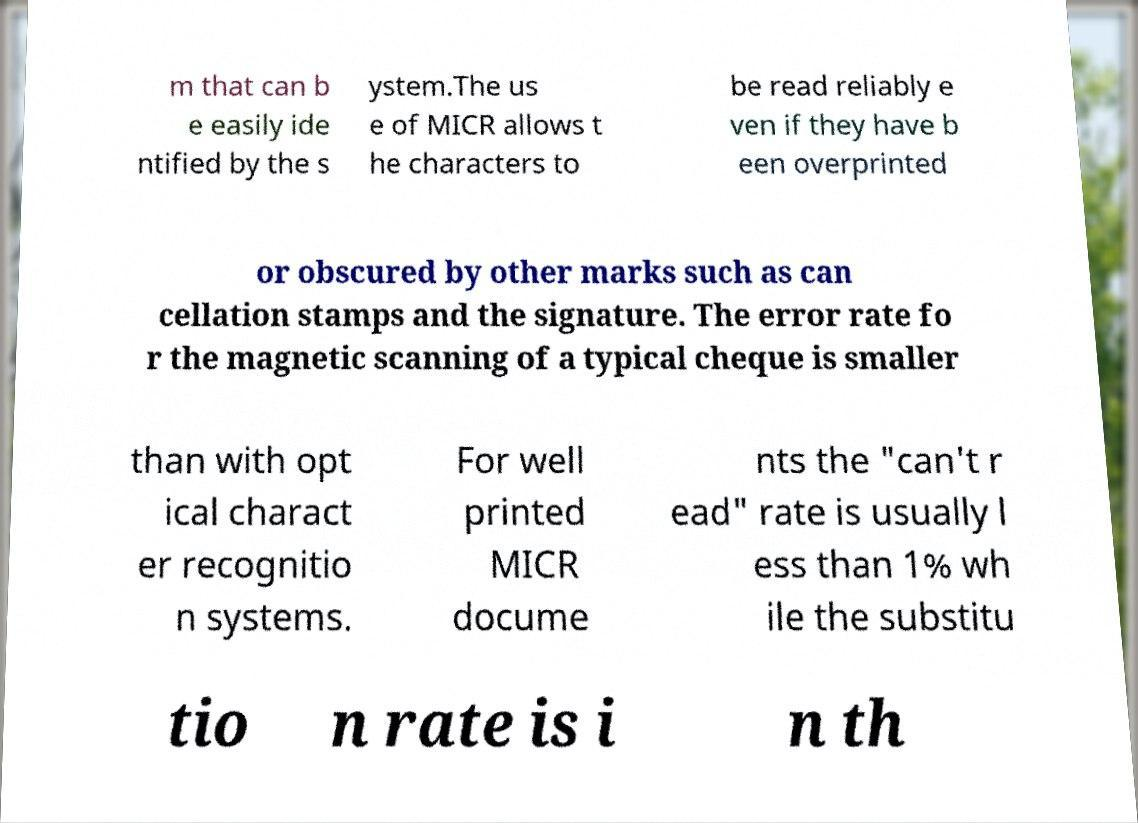Please read and relay the text visible in this image. What does it say? m that can b e easily ide ntified by the s ystem.The us e of MICR allows t he characters to be read reliably e ven if they have b een overprinted or obscured by other marks such as can cellation stamps and the signature. The error rate fo r the magnetic scanning of a typical cheque is smaller than with opt ical charact er recognitio n systems. For well printed MICR docume nts the "can't r ead" rate is usually l ess than 1% wh ile the substitu tio n rate is i n th 